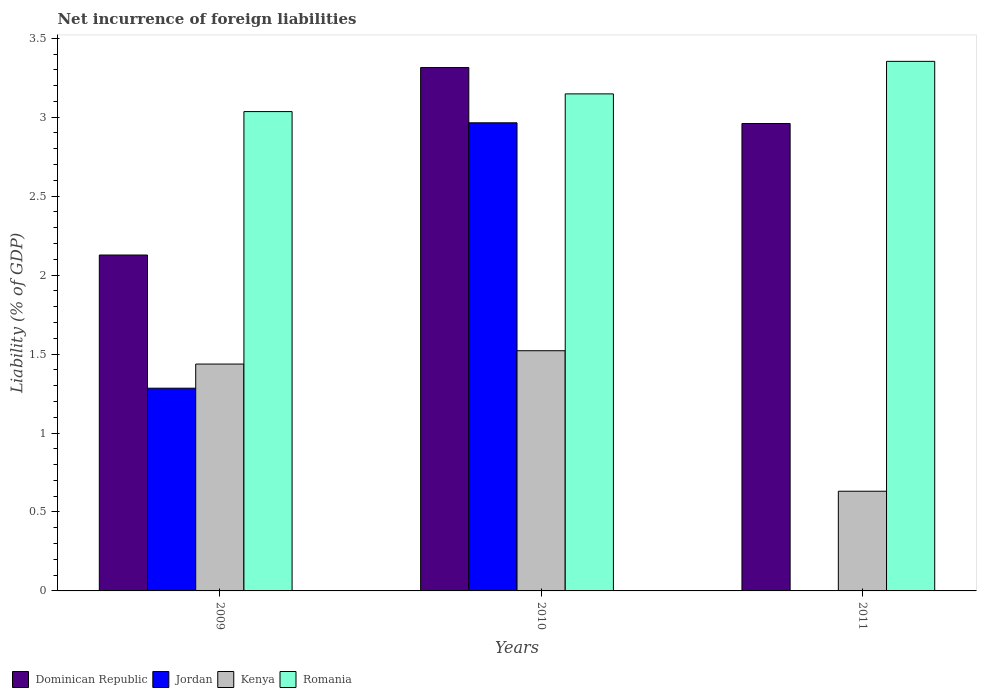Are the number of bars per tick equal to the number of legend labels?
Keep it short and to the point. No. Are the number of bars on each tick of the X-axis equal?
Provide a short and direct response. No. How many bars are there on the 2nd tick from the left?
Keep it short and to the point. 4. What is the label of the 3rd group of bars from the left?
Provide a succinct answer. 2011. What is the net incurrence of foreign liabilities in Romania in 2011?
Keep it short and to the point. 3.35. Across all years, what is the maximum net incurrence of foreign liabilities in Romania?
Offer a terse response. 3.35. Across all years, what is the minimum net incurrence of foreign liabilities in Dominican Republic?
Offer a terse response. 2.13. What is the total net incurrence of foreign liabilities in Romania in the graph?
Your answer should be very brief. 9.54. What is the difference between the net incurrence of foreign liabilities in Kenya in 2009 and that in 2011?
Offer a very short reply. 0.81. What is the difference between the net incurrence of foreign liabilities in Jordan in 2011 and the net incurrence of foreign liabilities in Romania in 2009?
Offer a very short reply. -3.04. What is the average net incurrence of foreign liabilities in Romania per year?
Offer a very short reply. 3.18. In the year 2011, what is the difference between the net incurrence of foreign liabilities in Romania and net incurrence of foreign liabilities in Dominican Republic?
Make the answer very short. 0.39. What is the ratio of the net incurrence of foreign liabilities in Kenya in 2009 to that in 2011?
Your answer should be compact. 2.28. Is the net incurrence of foreign liabilities in Kenya in 2010 less than that in 2011?
Offer a terse response. No. Is the difference between the net incurrence of foreign liabilities in Romania in 2009 and 2011 greater than the difference between the net incurrence of foreign liabilities in Dominican Republic in 2009 and 2011?
Ensure brevity in your answer.  Yes. What is the difference between the highest and the second highest net incurrence of foreign liabilities in Dominican Republic?
Provide a succinct answer. 0.35. What is the difference between the highest and the lowest net incurrence of foreign liabilities in Kenya?
Your response must be concise. 0.89. Is it the case that in every year, the sum of the net incurrence of foreign liabilities in Dominican Republic and net incurrence of foreign liabilities in Romania is greater than the sum of net incurrence of foreign liabilities in Jordan and net incurrence of foreign liabilities in Kenya?
Offer a very short reply. Yes. Is it the case that in every year, the sum of the net incurrence of foreign liabilities in Kenya and net incurrence of foreign liabilities in Romania is greater than the net incurrence of foreign liabilities in Jordan?
Give a very brief answer. Yes. How many bars are there?
Your response must be concise. 11. Are the values on the major ticks of Y-axis written in scientific E-notation?
Your response must be concise. No. Does the graph contain grids?
Make the answer very short. No. How many legend labels are there?
Make the answer very short. 4. How are the legend labels stacked?
Your answer should be compact. Horizontal. What is the title of the graph?
Provide a succinct answer. Net incurrence of foreign liabilities. Does "Bulgaria" appear as one of the legend labels in the graph?
Ensure brevity in your answer.  No. What is the label or title of the X-axis?
Your answer should be compact. Years. What is the label or title of the Y-axis?
Your answer should be very brief. Liability (% of GDP). What is the Liability (% of GDP) of Dominican Republic in 2009?
Provide a succinct answer. 2.13. What is the Liability (% of GDP) in Jordan in 2009?
Make the answer very short. 1.28. What is the Liability (% of GDP) in Kenya in 2009?
Your answer should be compact. 1.44. What is the Liability (% of GDP) of Romania in 2009?
Provide a succinct answer. 3.04. What is the Liability (% of GDP) of Dominican Republic in 2010?
Your response must be concise. 3.31. What is the Liability (% of GDP) in Jordan in 2010?
Keep it short and to the point. 2.96. What is the Liability (% of GDP) of Kenya in 2010?
Provide a succinct answer. 1.52. What is the Liability (% of GDP) of Romania in 2010?
Your answer should be compact. 3.15. What is the Liability (% of GDP) in Dominican Republic in 2011?
Ensure brevity in your answer.  2.96. What is the Liability (% of GDP) of Jordan in 2011?
Give a very brief answer. 0. What is the Liability (% of GDP) of Kenya in 2011?
Ensure brevity in your answer.  0.63. What is the Liability (% of GDP) of Romania in 2011?
Give a very brief answer. 3.35. Across all years, what is the maximum Liability (% of GDP) of Dominican Republic?
Provide a succinct answer. 3.31. Across all years, what is the maximum Liability (% of GDP) in Jordan?
Give a very brief answer. 2.96. Across all years, what is the maximum Liability (% of GDP) of Kenya?
Your response must be concise. 1.52. Across all years, what is the maximum Liability (% of GDP) of Romania?
Ensure brevity in your answer.  3.35. Across all years, what is the minimum Liability (% of GDP) in Dominican Republic?
Keep it short and to the point. 2.13. Across all years, what is the minimum Liability (% of GDP) of Jordan?
Offer a very short reply. 0. Across all years, what is the minimum Liability (% of GDP) of Kenya?
Your response must be concise. 0.63. Across all years, what is the minimum Liability (% of GDP) of Romania?
Offer a very short reply. 3.04. What is the total Liability (% of GDP) in Dominican Republic in the graph?
Offer a terse response. 8.4. What is the total Liability (% of GDP) in Jordan in the graph?
Ensure brevity in your answer.  4.25. What is the total Liability (% of GDP) in Kenya in the graph?
Make the answer very short. 3.59. What is the total Liability (% of GDP) in Romania in the graph?
Your answer should be compact. 9.54. What is the difference between the Liability (% of GDP) of Dominican Republic in 2009 and that in 2010?
Provide a short and direct response. -1.19. What is the difference between the Liability (% of GDP) in Jordan in 2009 and that in 2010?
Ensure brevity in your answer.  -1.68. What is the difference between the Liability (% of GDP) in Kenya in 2009 and that in 2010?
Your answer should be very brief. -0.08. What is the difference between the Liability (% of GDP) in Romania in 2009 and that in 2010?
Provide a short and direct response. -0.11. What is the difference between the Liability (% of GDP) in Dominican Republic in 2009 and that in 2011?
Give a very brief answer. -0.83. What is the difference between the Liability (% of GDP) in Kenya in 2009 and that in 2011?
Offer a very short reply. 0.81. What is the difference between the Liability (% of GDP) of Romania in 2009 and that in 2011?
Ensure brevity in your answer.  -0.32. What is the difference between the Liability (% of GDP) of Dominican Republic in 2010 and that in 2011?
Your answer should be very brief. 0.35. What is the difference between the Liability (% of GDP) of Kenya in 2010 and that in 2011?
Ensure brevity in your answer.  0.89. What is the difference between the Liability (% of GDP) of Romania in 2010 and that in 2011?
Your answer should be very brief. -0.21. What is the difference between the Liability (% of GDP) of Dominican Republic in 2009 and the Liability (% of GDP) of Jordan in 2010?
Ensure brevity in your answer.  -0.84. What is the difference between the Liability (% of GDP) in Dominican Republic in 2009 and the Liability (% of GDP) in Kenya in 2010?
Provide a succinct answer. 0.61. What is the difference between the Liability (% of GDP) of Dominican Republic in 2009 and the Liability (% of GDP) of Romania in 2010?
Offer a terse response. -1.02. What is the difference between the Liability (% of GDP) of Jordan in 2009 and the Liability (% of GDP) of Kenya in 2010?
Give a very brief answer. -0.24. What is the difference between the Liability (% of GDP) in Jordan in 2009 and the Liability (% of GDP) in Romania in 2010?
Keep it short and to the point. -1.86. What is the difference between the Liability (% of GDP) of Kenya in 2009 and the Liability (% of GDP) of Romania in 2010?
Offer a very short reply. -1.71. What is the difference between the Liability (% of GDP) of Dominican Republic in 2009 and the Liability (% of GDP) of Kenya in 2011?
Your answer should be very brief. 1.5. What is the difference between the Liability (% of GDP) of Dominican Republic in 2009 and the Liability (% of GDP) of Romania in 2011?
Your answer should be compact. -1.23. What is the difference between the Liability (% of GDP) of Jordan in 2009 and the Liability (% of GDP) of Kenya in 2011?
Offer a terse response. 0.65. What is the difference between the Liability (% of GDP) in Jordan in 2009 and the Liability (% of GDP) in Romania in 2011?
Offer a terse response. -2.07. What is the difference between the Liability (% of GDP) of Kenya in 2009 and the Liability (% of GDP) of Romania in 2011?
Offer a terse response. -1.92. What is the difference between the Liability (% of GDP) in Dominican Republic in 2010 and the Liability (% of GDP) in Kenya in 2011?
Provide a succinct answer. 2.68. What is the difference between the Liability (% of GDP) of Dominican Republic in 2010 and the Liability (% of GDP) of Romania in 2011?
Your answer should be very brief. -0.04. What is the difference between the Liability (% of GDP) of Jordan in 2010 and the Liability (% of GDP) of Kenya in 2011?
Provide a short and direct response. 2.33. What is the difference between the Liability (% of GDP) of Jordan in 2010 and the Liability (% of GDP) of Romania in 2011?
Ensure brevity in your answer.  -0.39. What is the difference between the Liability (% of GDP) in Kenya in 2010 and the Liability (% of GDP) in Romania in 2011?
Offer a terse response. -1.83. What is the average Liability (% of GDP) in Dominican Republic per year?
Make the answer very short. 2.8. What is the average Liability (% of GDP) in Jordan per year?
Offer a terse response. 1.42. What is the average Liability (% of GDP) of Kenya per year?
Make the answer very short. 1.2. What is the average Liability (% of GDP) in Romania per year?
Your answer should be very brief. 3.18. In the year 2009, what is the difference between the Liability (% of GDP) of Dominican Republic and Liability (% of GDP) of Jordan?
Provide a short and direct response. 0.84. In the year 2009, what is the difference between the Liability (% of GDP) in Dominican Republic and Liability (% of GDP) in Kenya?
Your answer should be very brief. 0.69. In the year 2009, what is the difference between the Liability (% of GDP) in Dominican Republic and Liability (% of GDP) in Romania?
Your answer should be compact. -0.91. In the year 2009, what is the difference between the Liability (% of GDP) of Jordan and Liability (% of GDP) of Kenya?
Provide a short and direct response. -0.15. In the year 2009, what is the difference between the Liability (% of GDP) in Jordan and Liability (% of GDP) in Romania?
Your response must be concise. -1.75. In the year 2009, what is the difference between the Liability (% of GDP) in Kenya and Liability (% of GDP) in Romania?
Make the answer very short. -1.6. In the year 2010, what is the difference between the Liability (% of GDP) of Dominican Republic and Liability (% of GDP) of Jordan?
Your response must be concise. 0.35. In the year 2010, what is the difference between the Liability (% of GDP) in Dominican Republic and Liability (% of GDP) in Kenya?
Your answer should be very brief. 1.79. In the year 2010, what is the difference between the Liability (% of GDP) in Dominican Republic and Liability (% of GDP) in Romania?
Your answer should be compact. 0.17. In the year 2010, what is the difference between the Liability (% of GDP) in Jordan and Liability (% of GDP) in Kenya?
Your response must be concise. 1.44. In the year 2010, what is the difference between the Liability (% of GDP) in Jordan and Liability (% of GDP) in Romania?
Provide a succinct answer. -0.18. In the year 2010, what is the difference between the Liability (% of GDP) in Kenya and Liability (% of GDP) in Romania?
Keep it short and to the point. -1.63. In the year 2011, what is the difference between the Liability (% of GDP) in Dominican Republic and Liability (% of GDP) in Kenya?
Your answer should be very brief. 2.33. In the year 2011, what is the difference between the Liability (% of GDP) of Dominican Republic and Liability (% of GDP) of Romania?
Make the answer very short. -0.39. In the year 2011, what is the difference between the Liability (% of GDP) in Kenya and Liability (% of GDP) in Romania?
Keep it short and to the point. -2.72. What is the ratio of the Liability (% of GDP) of Dominican Republic in 2009 to that in 2010?
Your answer should be compact. 0.64. What is the ratio of the Liability (% of GDP) of Jordan in 2009 to that in 2010?
Provide a succinct answer. 0.43. What is the ratio of the Liability (% of GDP) of Kenya in 2009 to that in 2010?
Keep it short and to the point. 0.94. What is the ratio of the Liability (% of GDP) in Romania in 2009 to that in 2010?
Offer a terse response. 0.96. What is the ratio of the Liability (% of GDP) in Dominican Republic in 2009 to that in 2011?
Provide a succinct answer. 0.72. What is the ratio of the Liability (% of GDP) in Kenya in 2009 to that in 2011?
Give a very brief answer. 2.28. What is the ratio of the Liability (% of GDP) in Romania in 2009 to that in 2011?
Offer a very short reply. 0.91. What is the ratio of the Liability (% of GDP) of Dominican Republic in 2010 to that in 2011?
Your response must be concise. 1.12. What is the ratio of the Liability (% of GDP) in Kenya in 2010 to that in 2011?
Ensure brevity in your answer.  2.41. What is the ratio of the Liability (% of GDP) in Romania in 2010 to that in 2011?
Your answer should be compact. 0.94. What is the difference between the highest and the second highest Liability (% of GDP) of Dominican Republic?
Provide a short and direct response. 0.35. What is the difference between the highest and the second highest Liability (% of GDP) in Kenya?
Keep it short and to the point. 0.08. What is the difference between the highest and the second highest Liability (% of GDP) of Romania?
Keep it short and to the point. 0.21. What is the difference between the highest and the lowest Liability (% of GDP) in Dominican Republic?
Offer a very short reply. 1.19. What is the difference between the highest and the lowest Liability (% of GDP) in Jordan?
Provide a succinct answer. 2.96. What is the difference between the highest and the lowest Liability (% of GDP) in Kenya?
Offer a very short reply. 0.89. What is the difference between the highest and the lowest Liability (% of GDP) of Romania?
Provide a short and direct response. 0.32. 